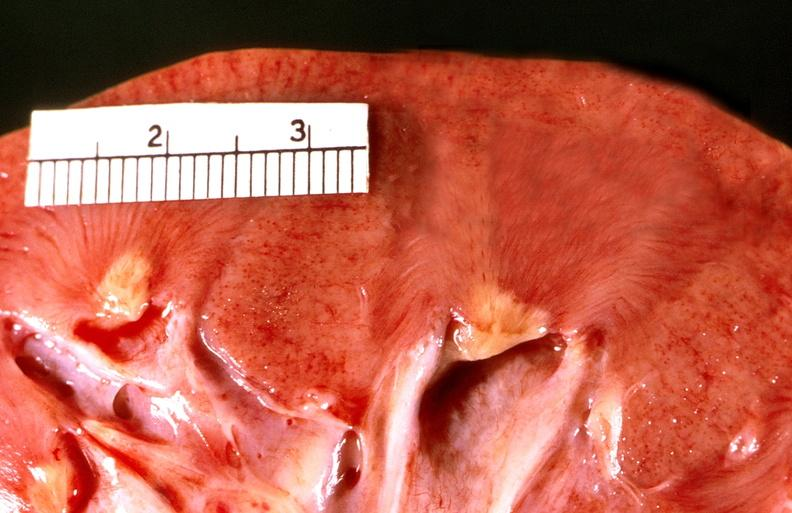where is this?
Answer the question using a single word or phrase. Urinary 